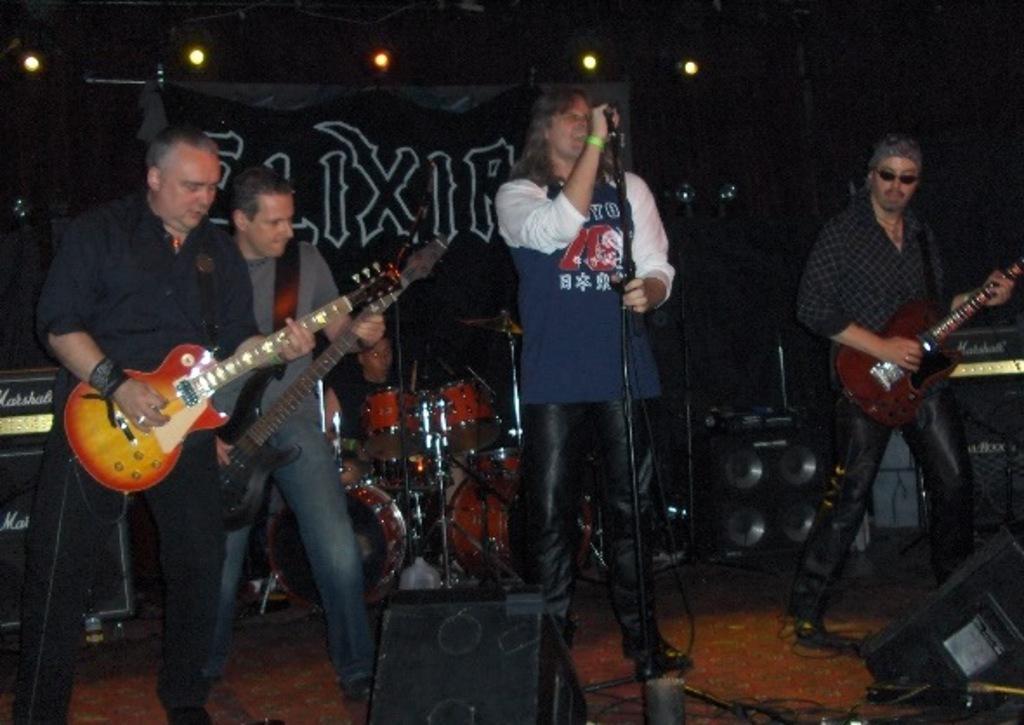Can you describe this image briefly? In this image, there are four person standing and playing guitar. Out of which one person is standing and singing a song in front of the mike. In the middle back one person is sitting and playing musical instruments. The background is dark in color. On the top focus lights are visible. On the stage sound boxes and speakers are visible. This image is taken inside a stage during night time. 